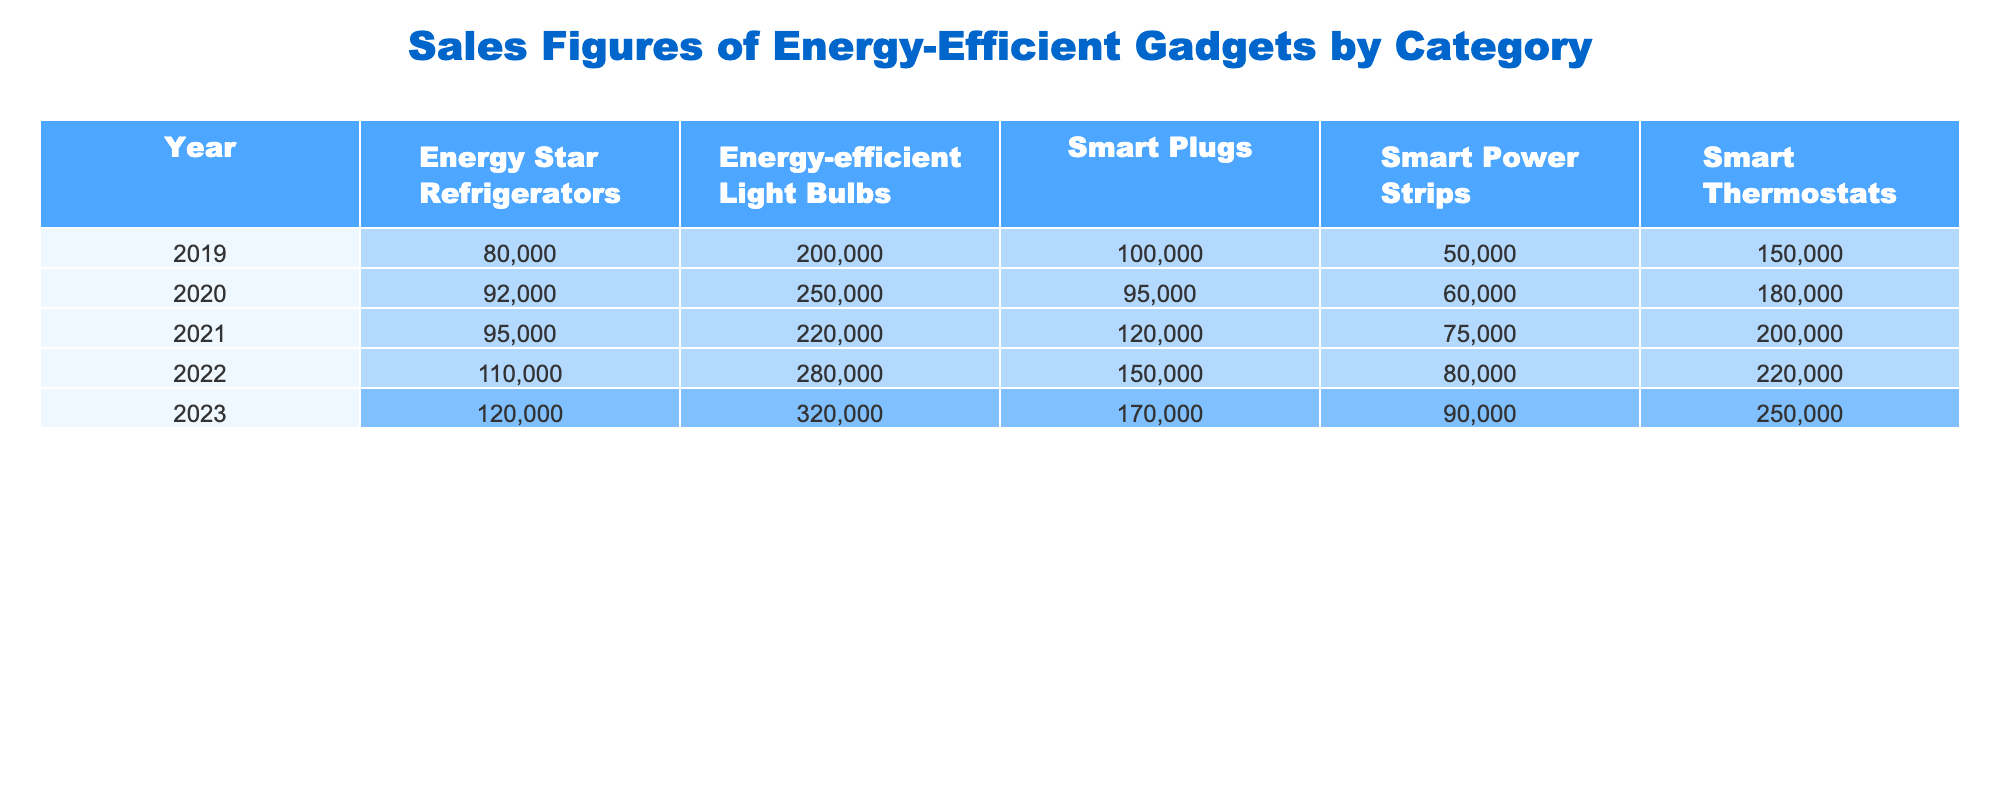What were the sales figures for Smart Thermostats in 2022? Looking at the row for 2022 in the Smart Thermostats column, the sales figure is 220,000 units.
Answer: 220000 Which category had the highest sales in 2023? For the year 2023, comparing the sales figures across categories, Energy-efficient Light Bulbs had the highest sales at 320,000 units.
Answer: Energy-efficient Light Bulbs What is the total sales figure for Energy Star Refrigerators over the last five years? Adding the sales figures from each year: 80,000 (2019) + 92,000 (2020) + 95,000 (2021) + 110,000 (2022) + 120,000 (2023) = 497,000.
Answer: 497000 Did sales of Smart Plugs increase every year from 2019 to 2023? Observing the sales figures for Smart Plugs: 100,000 (2019), 95,000 (2020), 120,000 (2021), 150,000 (2022), and 170,000 (2023), sales did not increase in 2020 compared to 2019, so the statement is false.
Answer: No What was the average sales figure for Energy-efficient Light Bulbs from 2019 to 2023? Summing the sales figures gives: 200,000 (2019) + 250,000 (2020) + 220,000 (2021) + 280,000 (2022) + 320,000 (2023) = 1,270,000. Dividing by 5 (the number of years) results in an average of 254,000.
Answer: 254000 In which year did Smart Power Strips achieve their highest sales? Looking across the years, the highest sales for Smart Power Strips is in 2022, with 80,000 units sold.
Answer: 2022 What is the difference in sales figures for Smart Thermostats between 2019 and 2023? The sales figures are 150,000 (2019) and 250,000 (2023). The difference is 250,000 - 150,000 = 100,000.
Answer: 100000 Which product had the lowest sales in 2020? In 2020, reviewing each category, the Smart Power Strips had the lowest sales figure of 60,000 units.
Answer: Smart Power Strips How many total units of Smart Thermostats were sold from 2019 to 2023? The total is calculated by adding the sales for each year: 150,000 (2019) + 180,000 (2020) + 200,000 (2021) + 220,000 (2022) + 250,000 (2023) = 1,000,000.
Answer: 1000000 Which category's sales figures did not reach 100,000 in 2019? In 2019, Smart Power Strips had sales of only 50,000 units, which is under 100,000.
Answer: Smart Power Strips 